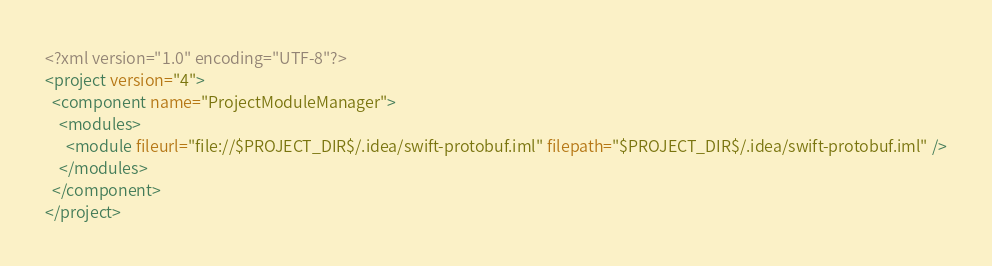Convert code to text. <code><loc_0><loc_0><loc_500><loc_500><_XML_><?xml version="1.0" encoding="UTF-8"?>
<project version="4">
  <component name="ProjectModuleManager">
    <modules>
      <module fileurl="file://$PROJECT_DIR$/.idea/swift-protobuf.iml" filepath="$PROJECT_DIR$/.idea/swift-protobuf.iml" />
    </modules>
  </component>
</project></code> 